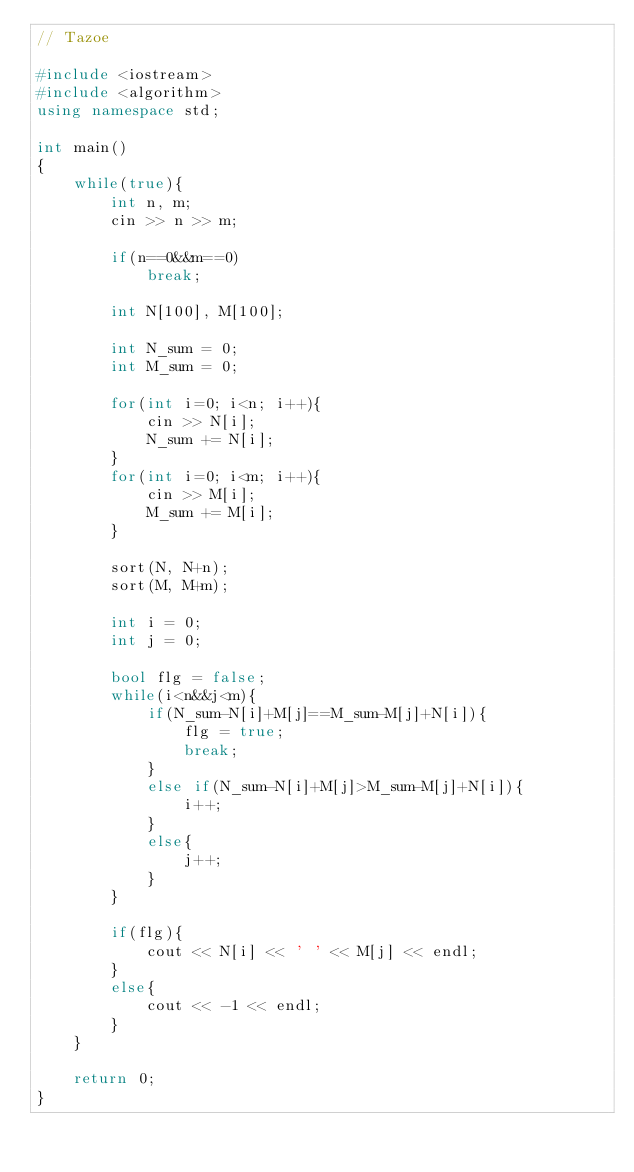<code> <loc_0><loc_0><loc_500><loc_500><_C++_>// Tazoe

#include <iostream>
#include <algorithm>
using namespace std;

int main()
{
	while(true){
		int n, m;
		cin >> n >> m;

		if(n==0&&m==0)
			break;

		int N[100], M[100];

		int N_sum = 0;
		int M_sum = 0;

		for(int i=0; i<n; i++){
			cin >> N[i];
			N_sum += N[i];
		}
		for(int i=0; i<m; i++){
			cin >> M[i];
			M_sum += M[i];
		}

		sort(N, N+n);
		sort(M, M+m);

		int i = 0;
		int j = 0;

		bool flg = false;
		while(i<n&&j<m){
			if(N_sum-N[i]+M[j]==M_sum-M[j]+N[i]){
				flg = true;
				break;
			}
			else if(N_sum-N[i]+M[j]>M_sum-M[j]+N[i]){
				i++;
			}
			else{
				j++;
			}
		}

		if(flg){
			cout << N[i] << ' ' << M[j] << endl;
		}
		else{
			cout << -1 << endl;
		}
	}

	return 0;
}</code> 